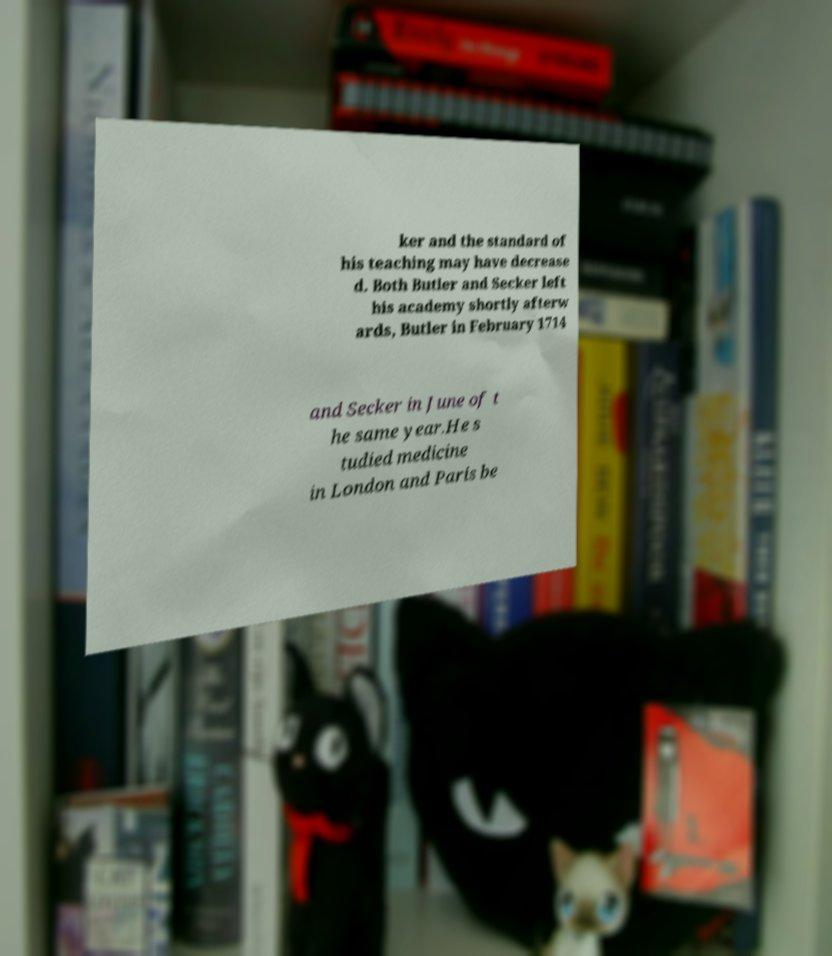What messages or text are displayed in this image? I need them in a readable, typed format. ker and the standard of his teaching may have decrease d. Both Butler and Secker left his academy shortly afterw ards, Butler in February 1714 and Secker in June of t he same year.He s tudied medicine in London and Paris be 